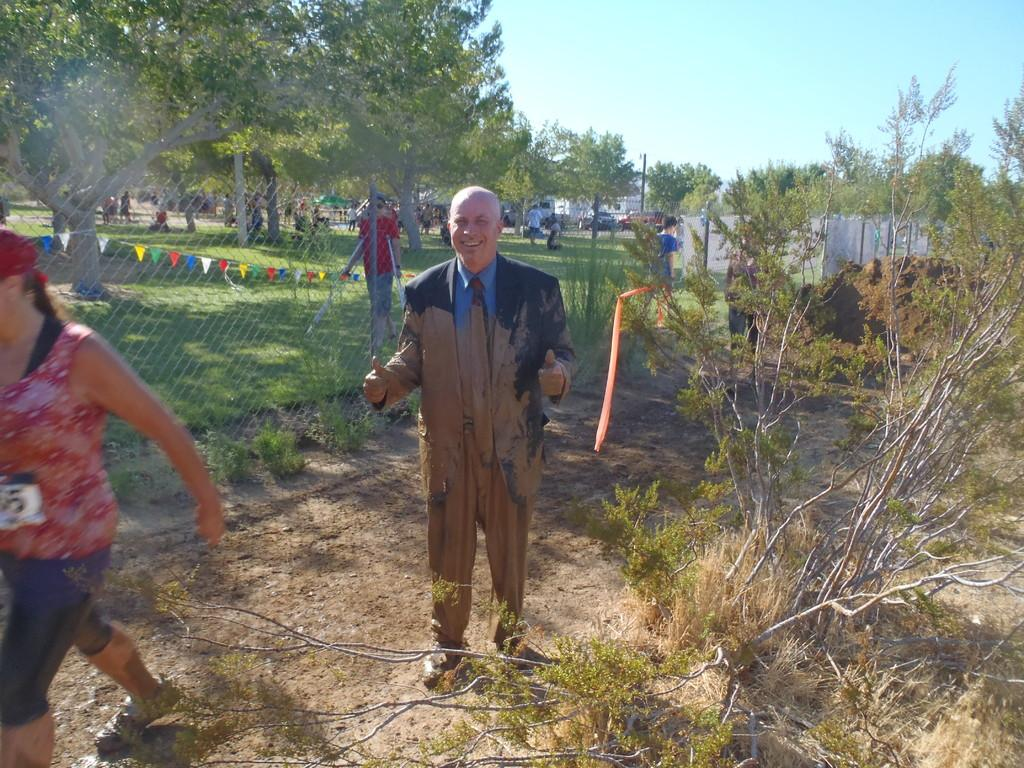How many people can be seen in the image? There are people in the image, but the exact number is not specified. What type of surface is visible beneath the people? The ground is visible in the image. What type of vegetation is present in the image? There is grass and plants visible in the image. What type of structures are present in the image? Poles and a wall are visible in the image. What type of material is present in the image? Mesh is visible in the image. What type of objects are present in the image? Flags are present in the image. What type of natural elements are visible in the image? Trees are visible in the image. What type of man-made objects are present in the image? Vehicles are present in the image. What is visible in the background of the image? The sky is visible in the background of the image. What color is the crayon used to draw the pot in the image? There is no crayon or pot present in the image. What rule is being enforced by the people in the image? There is no indication of any rules or enforcement in the image. 